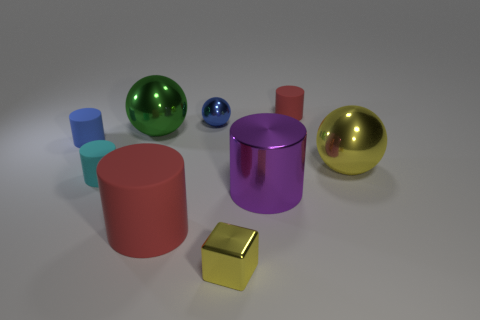Subtract all blue spheres. How many spheres are left? 2 Subtract all purple cubes. How many red cylinders are left? 2 Subtract all yellow balls. How many balls are left? 2 Subtract all blocks. How many objects are left? 8 Add 1 big spheres. How many objects exist? 10 Subtract 2 cylinders. How many cylinders are left? 3 Add 6 big green shiny balls. How many big green shiny balls exist? 7 Subtract 0 green blocks. How many objects are left? 9 Subtract all brown spheres. Subtract all cyan cubes. How many spheres are left? 3 Subtract all tiny cyan cylinders. Subtract all large balls. How many objects are left? 6 